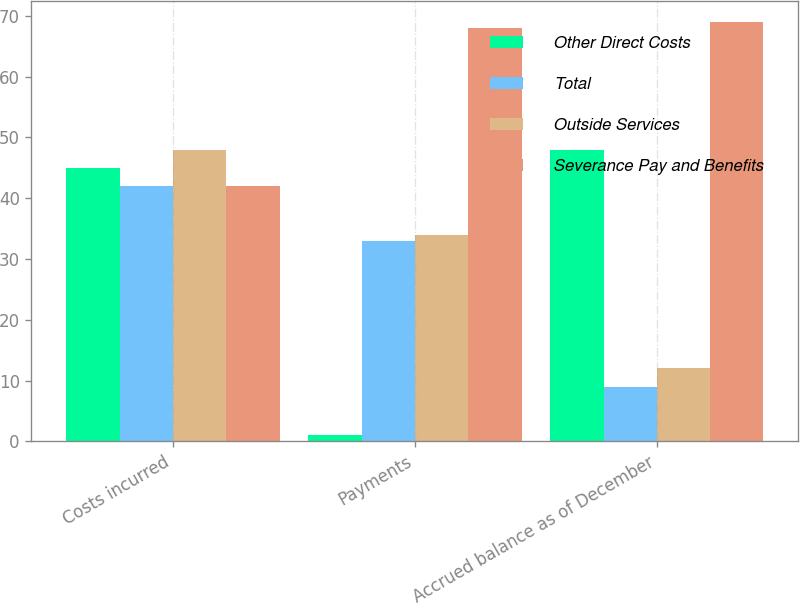Convert chart to OTSL. <chart><loc_0><loc_0><loc_500><loc_500><stacked_bar_chart><ecel><fcel>Costs incurred<fcel>Payments<fcel>Accrued balance as of December<nl><fcel>Other Direct Costs<fcel>45<fcel>1<fcel>48<nl><fcel>Total<fcel>42<fcel>33<fcel>9<nl><fcel>Outside Services<fcel>48<fcel>34<fcel>12<nl><fcel>Severance Pay and Benefits<fcel>42<fcel>68<fcel>69<nl></chart> 